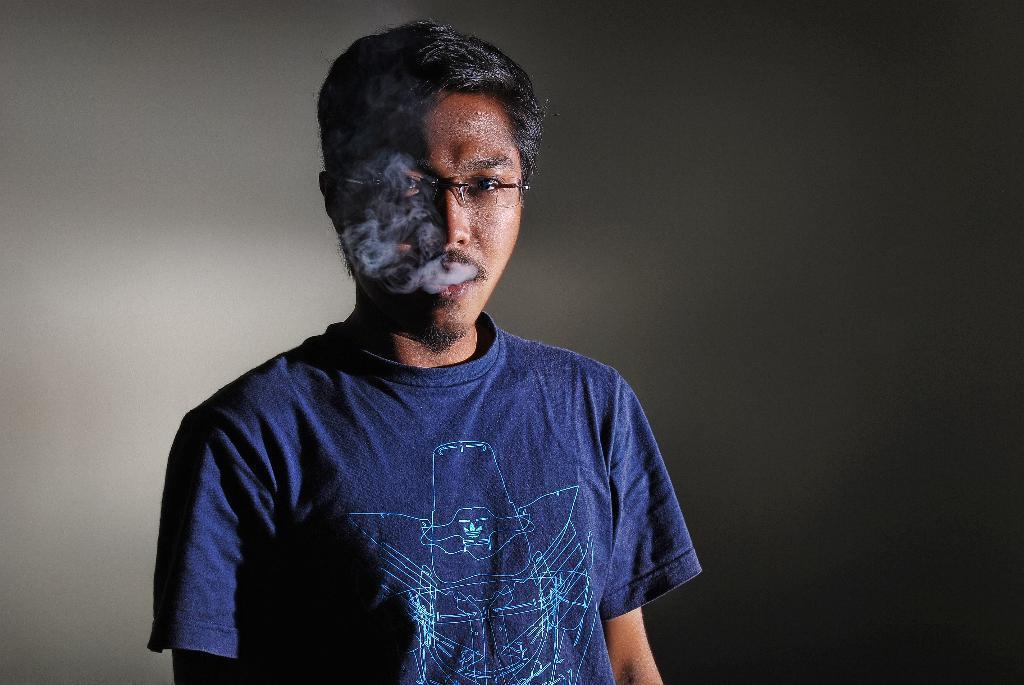Please provide a concise description of this image. Here we can see a man and there is smoke coming from his mouth. In the background we can see a wall. 